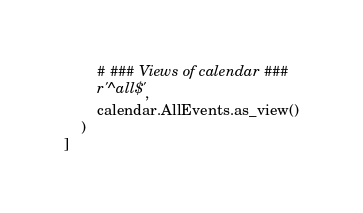Convert code to text. <code><loc_0><loc_0><loc_500><loc_500><_Python_>        # ### Views of calendar ###
        r'^all$',
        calendar.AllEvents.as_view()
    )
]
</code> 